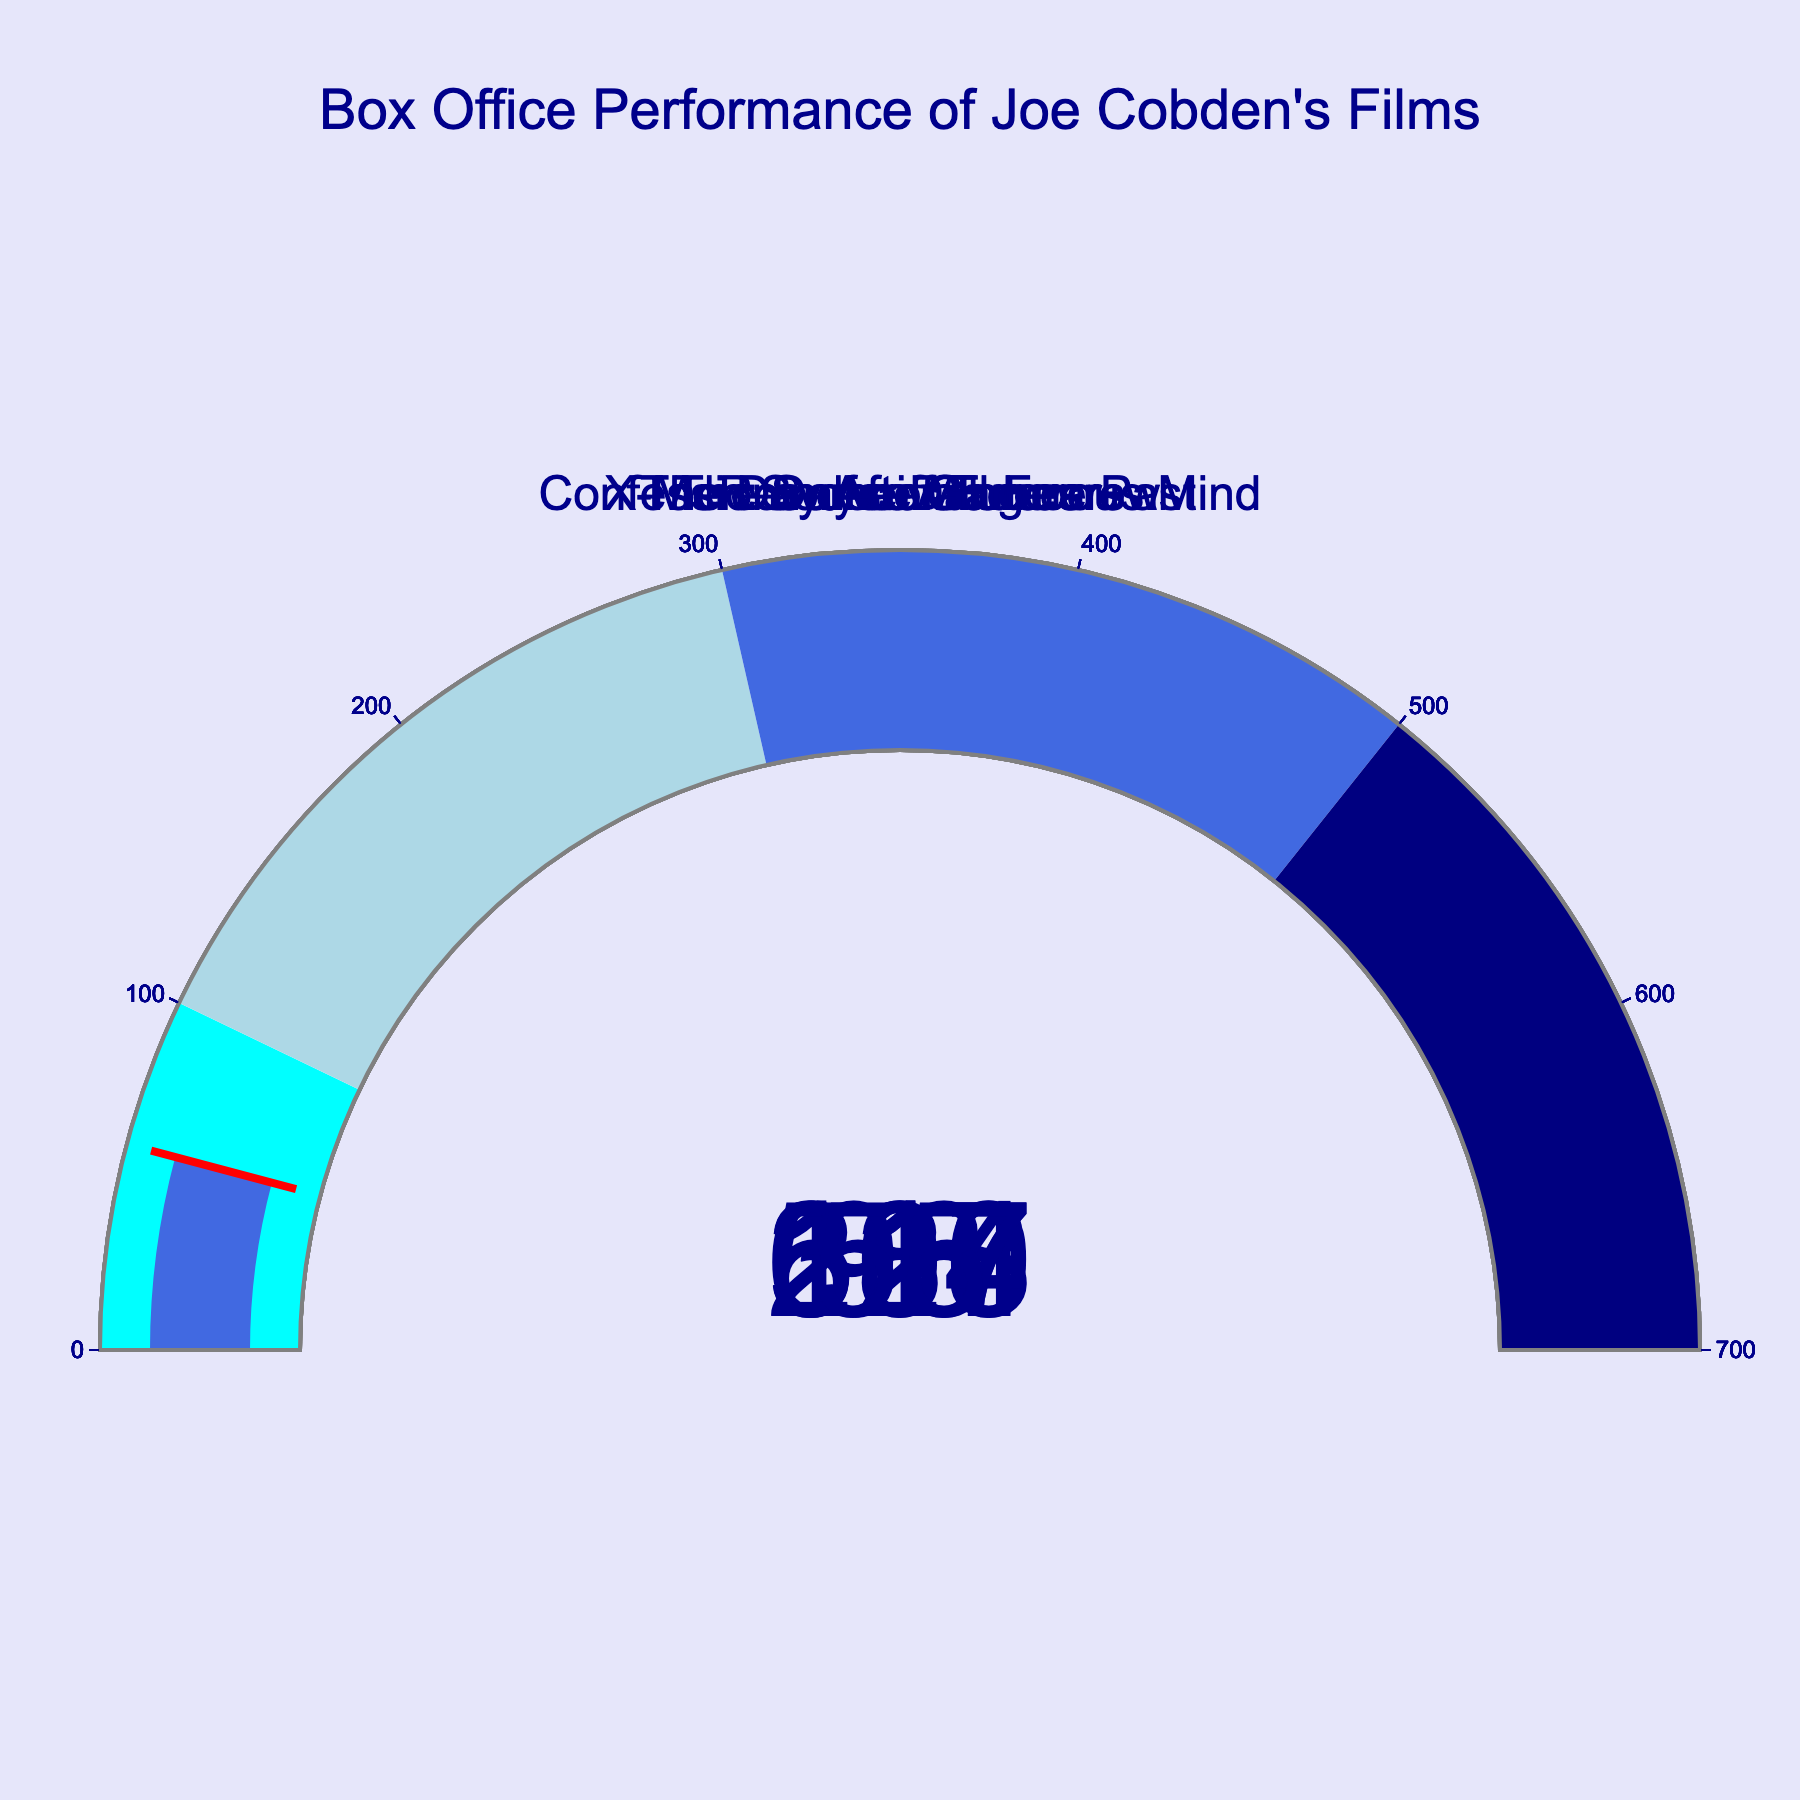What is the title of the figure? The title of the figure is placed at the top center of the graphic in a larger font size and reads: "Box Office Performance of Joe Cobden's Films".
Answer: Box Office Performance of Joe Cobden's Films How many films are depicted in the gauge chart? Each gauge represents one film, and there are seven gauges with their corresponding titles.
Answer: Seven Which film has the highest box office performance as a percentage of its budget? By identifying the gauge with the highest value and looking at the film title, "The Day After Tomorrow" has the highest percentage at 617%.
Answer: The Day After Tomorrow What color represents the bar for "Reindeer Games"? Each gauge bar has a distinct color, and for "Reindeer Games", the bar is displayed in royal blue.
Answer: Royal blue Which films have a box office performance below 200% of their budget? By examining the gauges, "Confessions of a Dangerous Mind" at 95%, "Reindeer Games" at 58%, and "Source Code" at 180% are below 200%.
Answer: Confessions of a Dangerous Mind, Reindeer Games, Source Code What is the combined box office performance percentage of "Source Code" and "The Sum of All Fears"? Adding the percentages for "Source Code" (180%) and "The Sum of All Fears" (207%) gives 180+207 = 387%.
Answer: 387% Which film's box office performance just surpasses the "light blue" performance step? "Arrival" is just above the light blue step (100 to 300) with a percentage of 328%, making it belong to the "royal blue" step.
Answer: Arrival How many films have a box office performance in the "royal blue" step (300-500%) range? By checking the gauges, "X-Men: Days of Future Past" with 514% and "Arrival" with 328% are categorized in the "royal blue" step.
Answer: Two Was "Confessions of a Dangerous Mind" a box office hit or flop in terms of percentage of budget? By examining the performance percentage (95%), it indicates performance below the 100% threshold, suggesting it didn’t recoup its budget.
Answer: Flop Which films have a performance percentage higher than 500%? Checking the gauges, "The Day After Tomorrow" with 617% and "X-Men: Days of Future Past" with 514% exceed the 500% mark.
Answer: The Day After Tomorrow, X-Men: Days of Future Past 